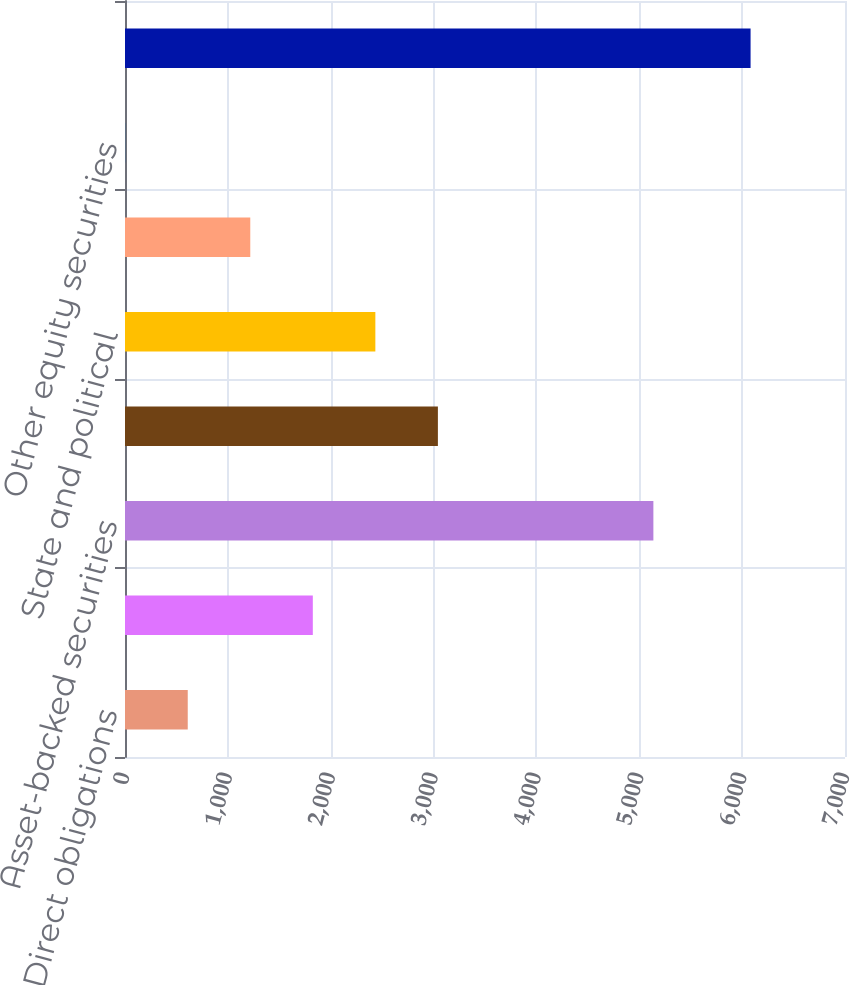Convert chart to OTSL. <chart><loc_0><loc_0><loc_500><loc_500><bar_chart><fcel>Direct obligations<fcel>Mortgage-backed securities<fcel>Asset-backed securities<fcel>Collateralized mortgage<fcel>State and political<fcel>Other debt investments<fcel>Other equity securities<fcel>Total<nl><fcel>610<fcel>1826<fcel>5137<fcel>3042<fcel>2434<fcel>1218<fcel>2<fcel>6082<nl></chart> 